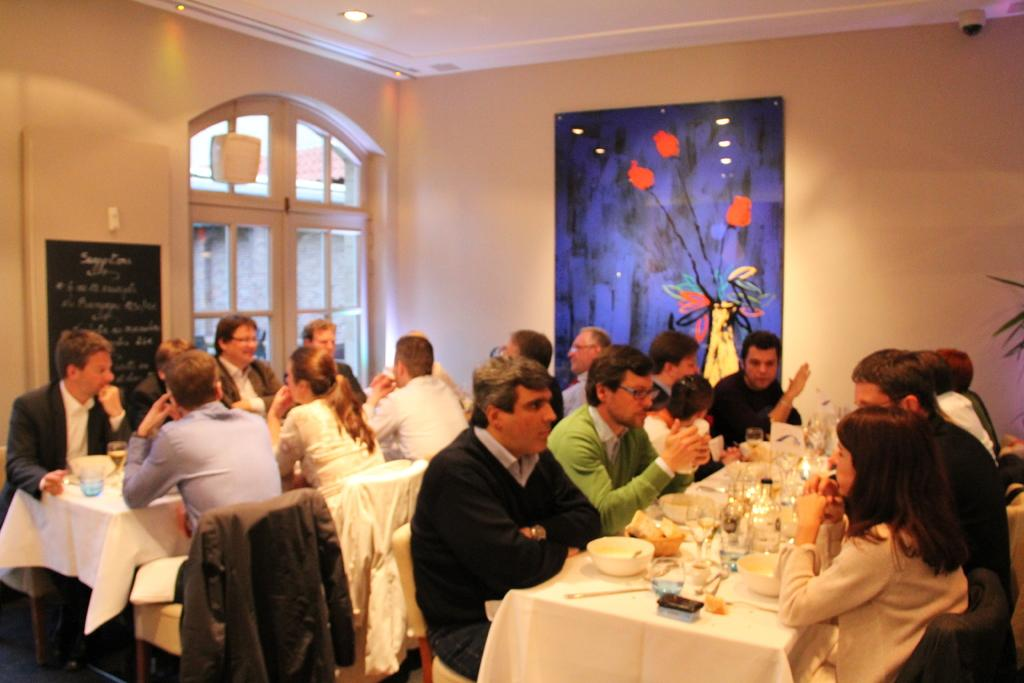What are the persons in the image doing? The persons in the image are sitting on chairs. What is in front of the persons? There is a table in front of the persons. What is on the table? There is a bowl and glasses on the table. What can be seen on the wall in the image? There is a painting on the wall. What type of hydrant is visible in the image? There is no hydrant present in the image. How is the distribution of the items on the table organized in the image? The provided facts do not give information about the distribution or organization of the items on the table. 